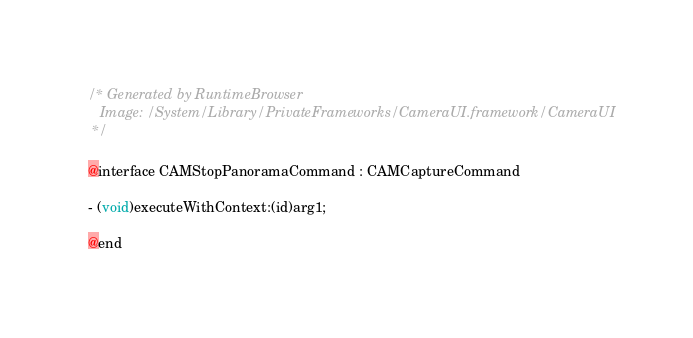<code> <loc_0><loc_0><loc_500><loc_500><_C_>/* Generated by RuntimeBrowser
   Image: /System/Library/PrivateFrameworks/CameraUI.framework/CameraUI
 */

@interface CAMStopPanoramaCommand : CAMCaptureCommand

- (void)executeWithContext:(id)arg1;

@end
</code> 